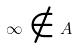<formula> <loc_0><loc_0><loc_500><loc_500>\infty \notin A</formula> 